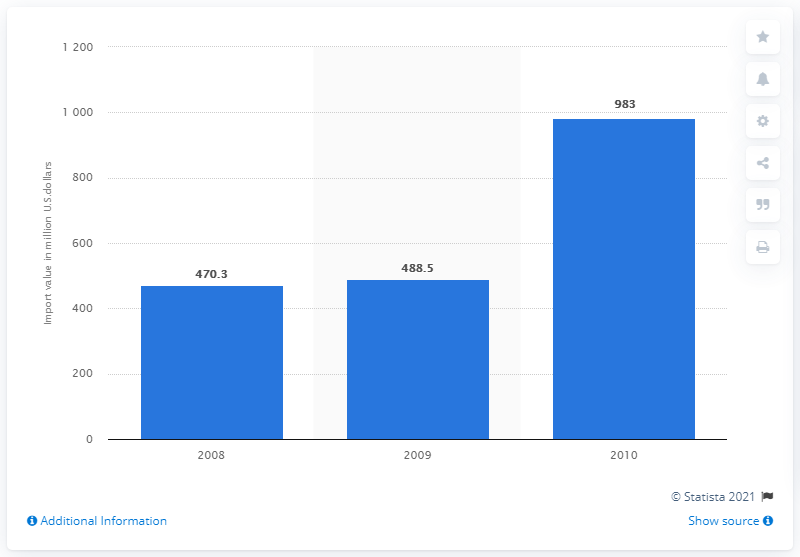Draw attention to some important aspects in this diagram. The value of U.S. imports of Christmas tree ornaments from China in 2008 was approximately 470.3 million dollars. 